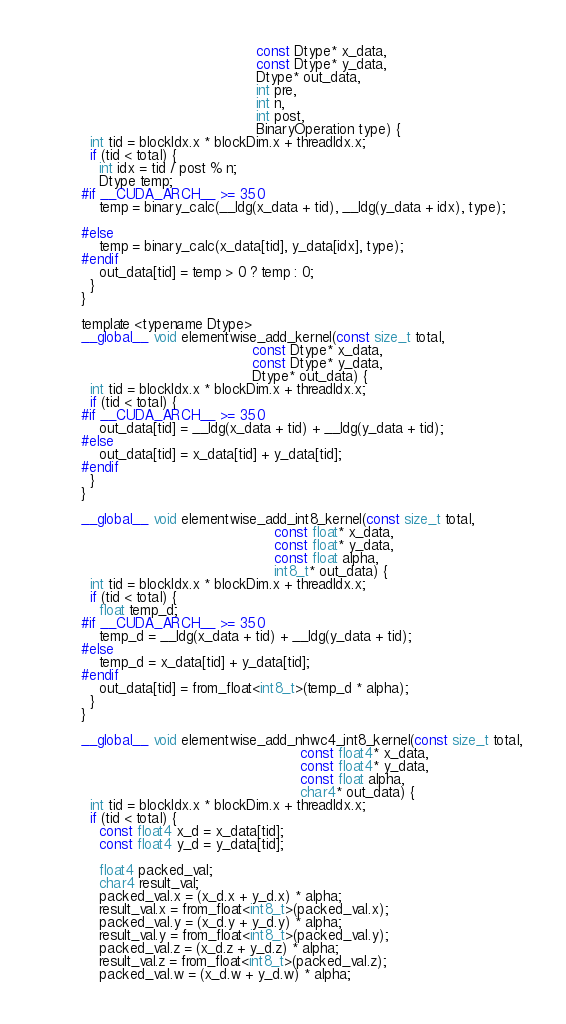Convert code to text. <code><loc_0><loc_0><loc_500><loc_500><_Cuda_>                                        const Dtype* x_data,
                                        const Dtype* y_data,
                                        Dtype* out_data,
                                        int pre,
                                        int n,
                                        int post,
                                        BinaryOperation type) {
  int tid = blockIdx.x * blockDim.x + threadIdx.x;
  if (tid < total) {
    int idx = tid / post % n;
    Dtype temp;
#if __CUDA_ARCH__ >= 350
    temp = binary_calc(__ldg(x_data + tid), __ldg(y_data + idx), type);

#else
    temp = binary_calc(x_data[tid], y_data[idx], type);
#endif
    out_data[tid] = temp > 0 ? temp : 0;
  }
}

template <typename Dtype>
__global__ void elementwise_add_kernel(const size_t total,
                                       const Dtype* x_data,
                                       const Dtype* y_data,
                                       Dtype* out_data) {
  int tid = blockIdx.x * blockDim.x + threadIdx.x;
  if (tid < total) {
#if __CUDA_ARCH__ >= 350
    out_data[tid] = __ldg(x_data + tid) + __ldg(y_data + tid);
#else
    out_data[tid] = x_data[tid] + y_data[tid];
#endif
  }
}

__global__ void elementwise_add_int8_kernel(const size_t total,
                                            const float* x_data,
                                            const float* y_data,
                                            const float alpha,
                                            int8_t* out_data) {
  int tid = blockIdx.x * blockDim.x + threadIdx.x;
  if (tid < total) {
    float temp_d;
#if __CUDA_ARCH__ >= 350
    temp_d = __ldg(x_data + tid) + __ldg(y_data + tid);
#else
    temp_d = x_data[tid] + y_data[tid];
#endif
    out_data[tid] = from_float<int8_t>(temp_d * alpha);
  }
}

__global__ void elementwise_add_nhwc4_int8_kernel(const size_t total,
                                                  const float4* x_data,
                                                  const float4* y_data,
                                                  const float alpha,
                                                  char4* out_data) {
  int tid = blockIdx.x * blockDim.x + threadIdx.x;
  if (tid < total) {
    const float4 x_d = x_data[tid];
    const float4 y_d = y_data[tid];

    float4 packed_val;
    char4 result_val;
    packed_val.x = (x_d.x + y_d.x) * alpha;
    result_val.x = from_float<int8_t>(packed_val.x);
    packed_val.y = (x_d.y + y_d.y) * alpha;
    result_val.y = from_float<int8_t>(packed_val.y);
    packed_val.z = (x_d.z + y_d.z) * alpha;
    result_val.z = from_float<int8_t>(packed_val.z);
    packed_val.w = (x_d.w + y_d.w) * alpha;</code> 